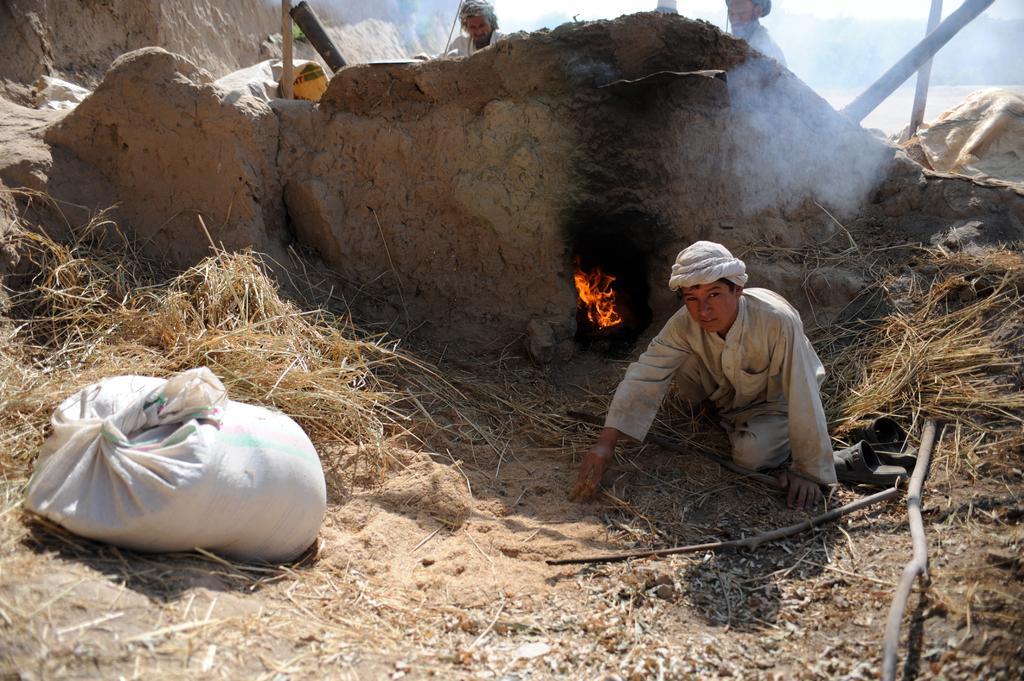Can you describe this image briefly? In this image, we can see a person sitting on the ground, there is a bag on the left, we can see fire, there are two persons standing in the background. 